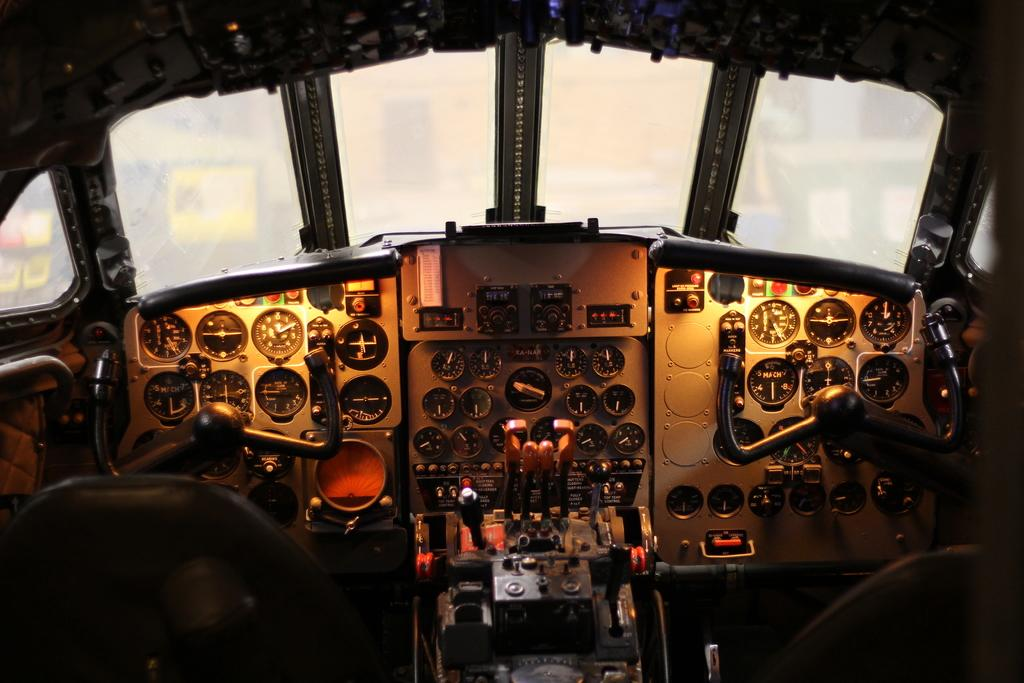Where was the image taken? The image was taken inside a vehicle. What can be seen inside the vehicle? There are display meters inside the vehicle. What type of windows are present in the vehicle? There are glass windows at the top of the vehicle. What is located at the bottom of the vehicle? There are seats at the bottom of the vehicle. How many chickens are visible in the image? There are no chickens present in the image. What time of day is it in the image, based on the hour displayed on the display meters? The image does not provide information about the time of day, as there is no mention of an hour displayed on the display meters. 